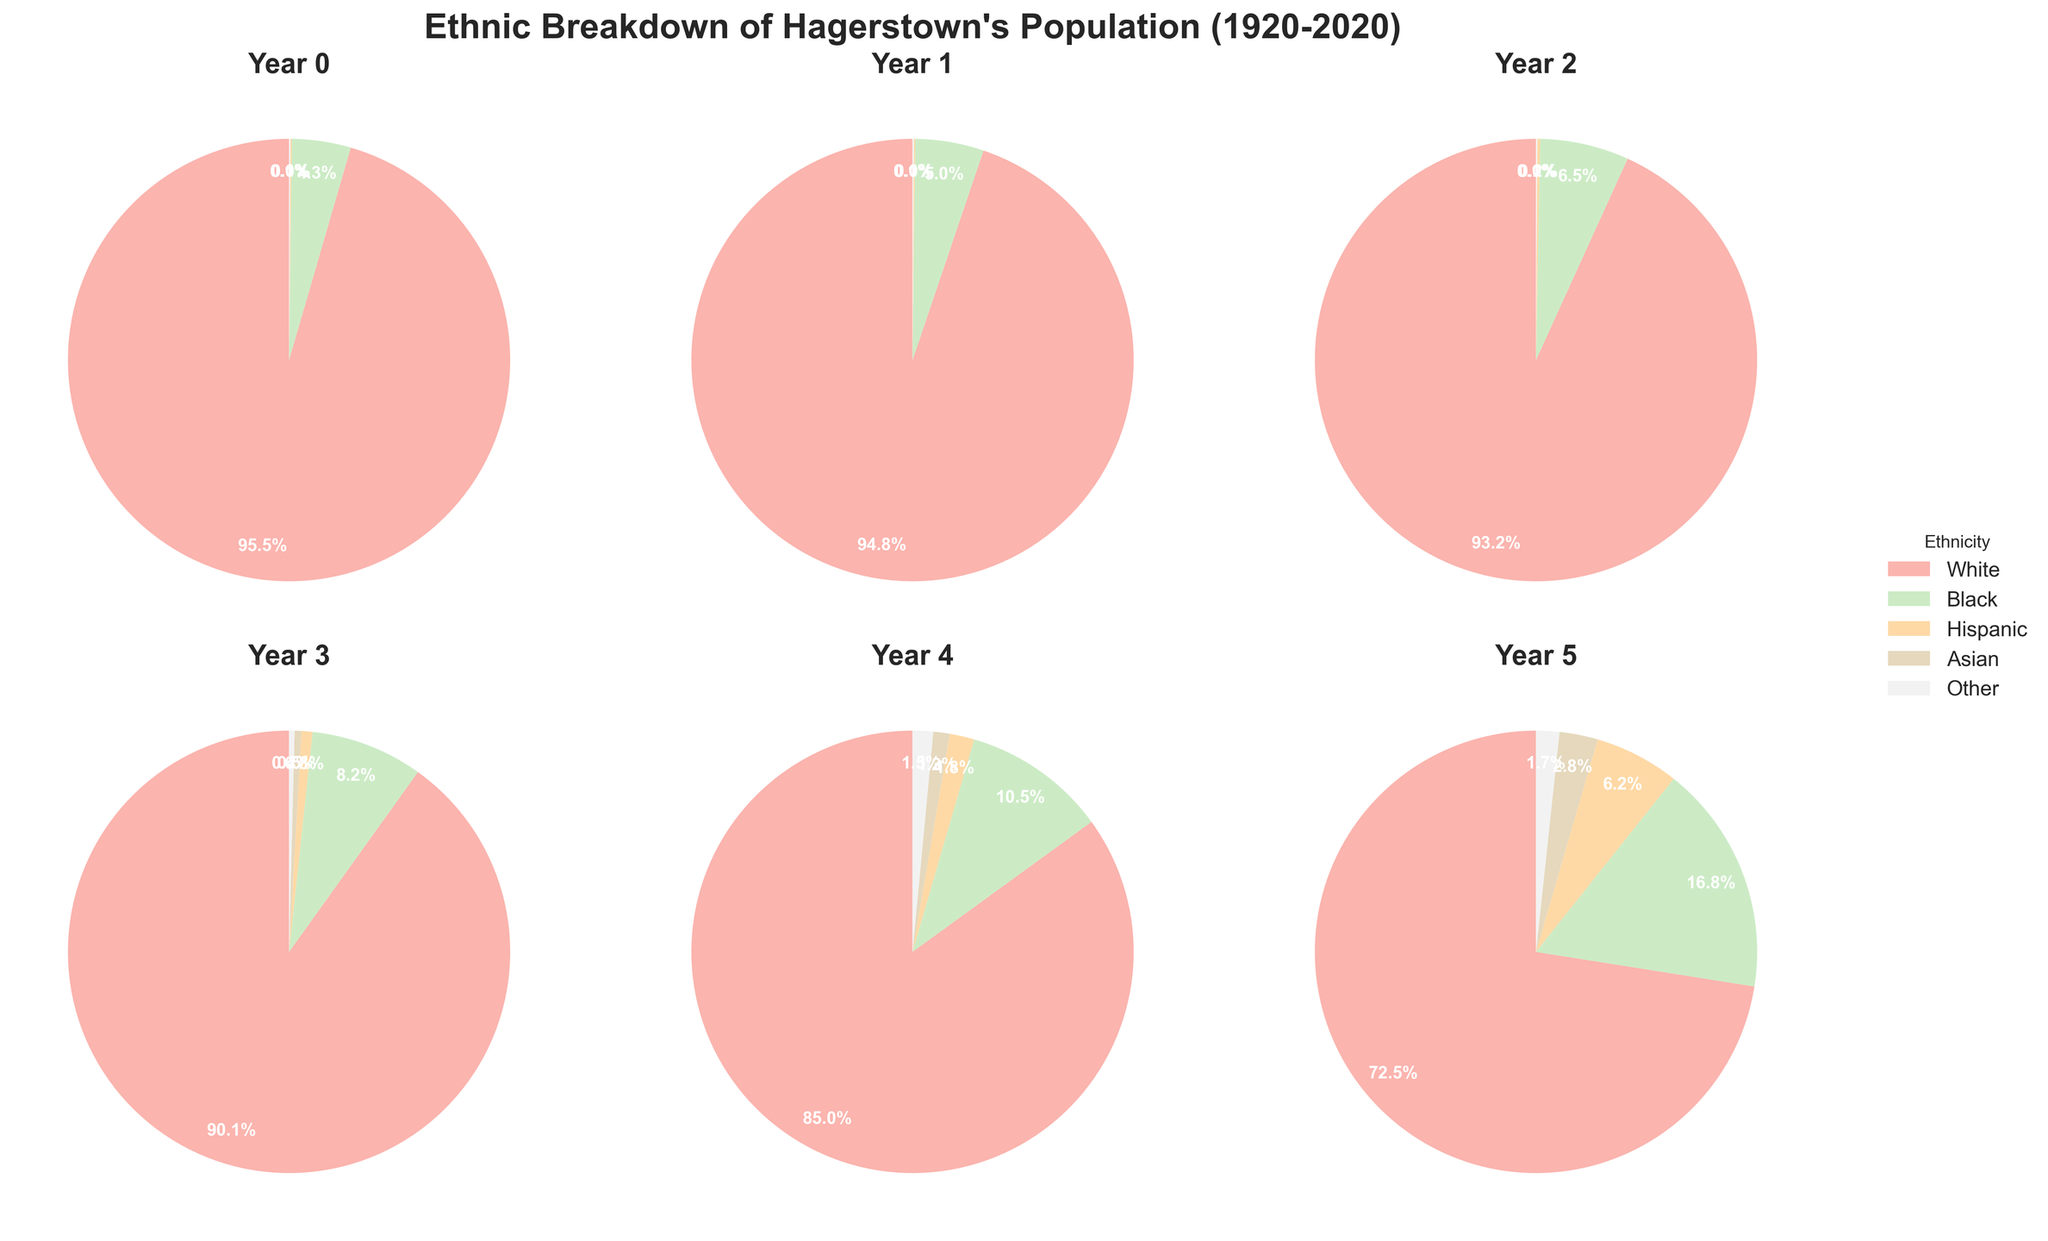Which ethnic group had the largest percentage increase from 1920 to 2020? To find the largest percentage increase, subtract the 1920 percentage from the 2020 percentage for each ethnic group: White (72.5 - 95.5 = -23), Black (16.8 - 4.3 = 12.5), Hispanic (6.2 - 0.1 = 6.1), Asian (2.8 - 0 = 2.8), Other (1.7 - 0.1 = 1.6). The Black ethnic group had the largest percentage increase (16.8 - 4.3 = 12.5).
Answer: Black Comparing the percentages of the Hispanic population, did it grow more between 1980 and 2000 or between 2000 and 2020? Subtract the Hispanic percentage in 1980 from 2000 to get the first growth: 1.8 - 0.8 = 1. The second growth is from 2000 to 2020: 6.2 - 1.8 = 4.4. The Hispanic population grew more between 2000 and 2020 (4.4) than between 1980 and 2000 (1).
Answer: Between 2000 and 2020 What is the smallest percentage of any ethnic group observed in any given year? Look at all the pie charts and find the smallest percentage for any ethnic group. Asian has the smallest percentage in multiple years (0.0% in 1920, 1940, and 1960).
Answer: 0.0% How did the percentage of the White population change over the entire 100 years? Subtract the 2020 percentage from the 1920 percentage: 95.5 - 72.5 = 23. The White population percentage decreased by 23 percentage points.
Answer: Decreased by 23 points Which year had the highest percentage of Asian population? Check each pie chart for the percentage values assigned to the Asian group: 0.0% (1920, 1940, 1960), 0.5% (1980), 1.2% (2000), and 2.8% (2020). The year 2020 had the highest at 2.8%.
Answer: 2020 Comparing 1960 and 1980, which ethnic group saw the largest percentage increase? Subtract the 1960 percentages from the 1980 percentages for each group: White (90.1 - 93.2 = -3.1), Black (8.2 - 6.5 = 1.7), Hispanic (0.8 - 0.2 = 0.6), Asian (0.5 - 0 = 0.5), and Other (0.4 - 0.1 = 0.3). The Black group saw the largest increase of 1.7 percentage points.
Answer: Black In which year was the combined percentage of Black, Hispanic, and Asian groups closest to 20%? Add the percentages of Black, Hispanic, and Asian groups for each year: 1920 (4.3 + 0.1 + 0.0 = 4.4), 1940 (5.0 + 0.1 + 0.0 = 5.1), 1960 (6.5 + 0.2 + 0.0 = 6.7), 1980 (8.2 + 0.8 + 0.5 = 9.5), 2000 (10.5 + 1.8 + 1.2 = 13.5), and 2020 (16.8 + 6.2 + 2.8 = 25.8). The closest combined percentage to 20% is 25.8% in 2020.
Answer: 2020 